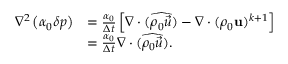Convert formula to latex. <formula><loc_0><loc_0><loc_500><loc_500>\begin{array} { r l } { \nabla ^ { 2 } \left ( \alpha _ { 0 } \delta p \right ) } & { = \frac { \alpha _ { 0 } } { \Delta t } \left [ \nabla \cdot ( \widehat { \rho _ { 0 } \vec { u } } ) - \nabla \cdot ( \rho _ { 0 } u ) ^ { k + 1 } \right ] } \\ & { = \frac { \alpha _ { 0 } } { \Delta t } \nabla \cdot ( \widehat { \rho _ { 0 } \vec { u } } ) . } \end{array}</formula> 